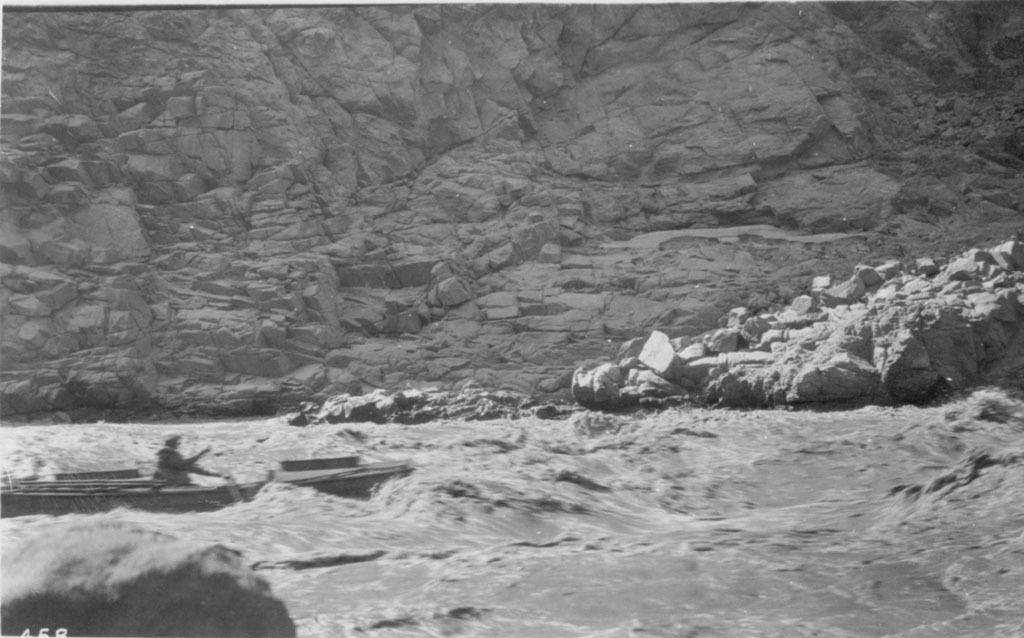Describe this image in one or two sentences. In this black and white image there is a person on the boat, which is in the river. In the background there is a mountain. 